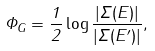Convert formula to latex. <formula><loc_0><loc_0><loc_500><loc_500>\Phi _ { G } = \frac { 1 } { 2 } \log \frac { \left | \Sigma ( E ) \right | } { \left | \Sigma ( E ^ { \prime } ) \right | } ,</formula> 